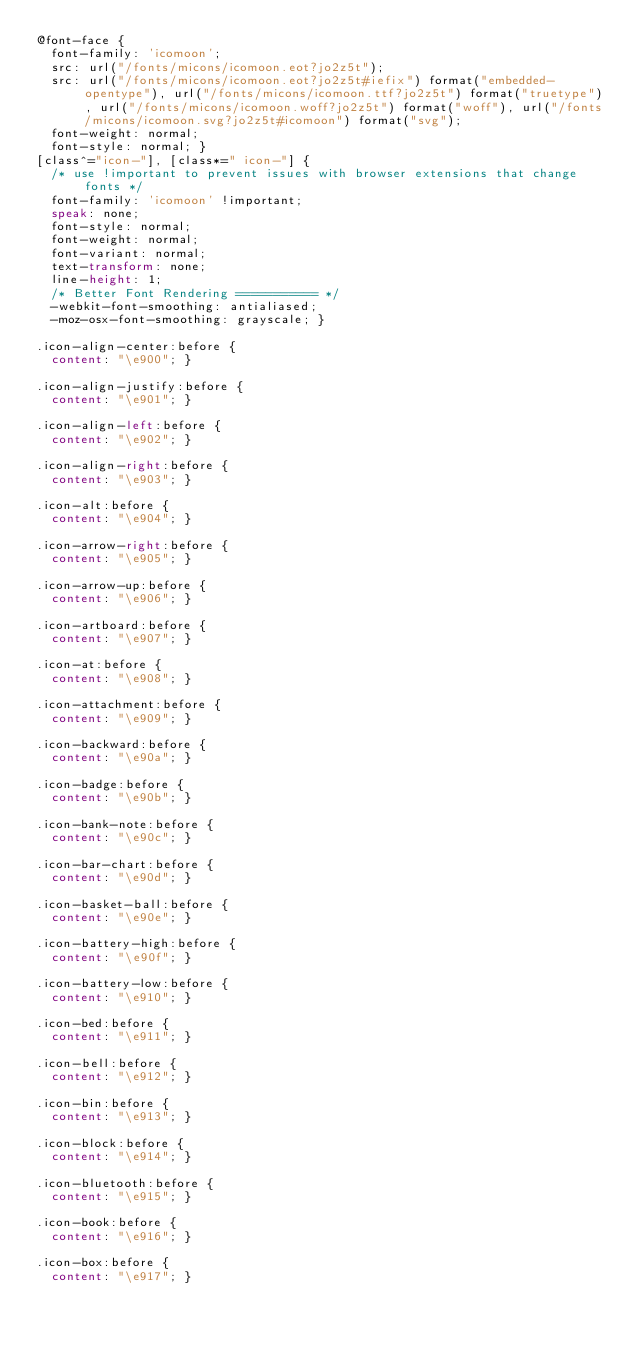Convert code to text. <code><loc_0><loc_0><loc_500><loc_500><_CSS_>@font-face {
  font-family: 'icomoon';
  src: url("/fonts/micons/icomoon.eot?jo2z5t");
  src: url("/fonts/micons/icomoon.eot?jo2z5t#iefix") format("embedded-opentype"), url("/fonts/micons/icomoon.ttf?jo2z5t") format("truetype"), url("/fonts/micons/icomoon.woff?jo2z5t") format("woff"), url("/fonts/micons/icomoon.svg?jo2z5t#icomoon") format("svg");
  font-weight: normal;
  font-style: normal; }
[class^="icon-"], [class*=" icon-"] {
  /* use !important to prevent issues with browser extensions that change fonts */
  font-family: 'icomoon' !important;
  speak: none;
  font-style: normal;
  font-weight: normal;
  font-variant: normal;
  text-transform: none;
  line-height: 1;
  /* Better Font Rendering =========== */
  -webkit-font-smoothing: antialiased;
  -moz-osx-font-smoothing: grayscale; }

.icon-align-center:before {
  content: "\e900"; }

.icon-align-justify:before {
  content: "\e901"; }

.icon-align-left:before {
  content: "\e902"; }

.icon-align-right:before {
  content: "\e903"; }

.icon-alt:before {
  content: "\e904"; }

.icon-arrow-right:before {
  content: "\e905"; }

.icon-arrow-up:before {
  content: "\e906"; }

.icon-artboard:before {
  content: "\e907"; }

.icon-at:before {
  content: "\e908"; }

.icon-attachment:before {
  content: "\e909"; }

.icon-backward:before {
  content: "\e90a"; }

.icon-badge:before {
  content: "\e90b"; }

.icon-bank-note:before {
  content: "\e90c"; }

.icon-bar-chart:before {
  content: "\e90d"; }

.icon-basket-ball:before {
  content: "\e90e"; }

.icon-battery-high:before {
  content: "\e90f"; }

.icon-battery-low:before {
  content: "\e910"; }

.icon-bed:before {
  content: "\e911"; }

.icon-bell:before {
  content: "\e912"; }

.icon-bin:before {
  content: "\e913"; }

.icon-block:before {
  content: "\e914"; }

.icon-bluetooth:before {
  content: "\e915"; }

.icon-book:before {
  content: "\e916"; }

.icon-box:before {
  content: "\e917"; }
</code> 